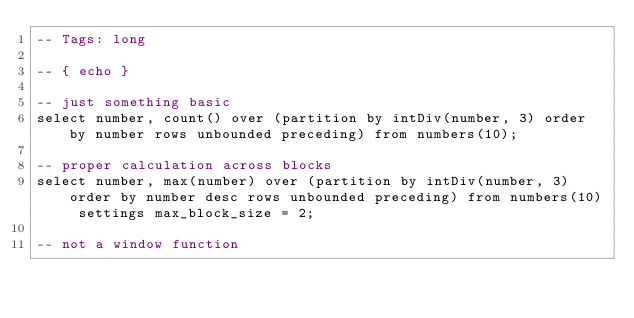Convert code to text. <code><loc_0><loc_0><loc_500><loc_500><_SQL_>-- Tags: long

-- { echo }

-- just something basic
select number, count() over (partition by intDiv(number, 3) order by number rows unbounded preceding) from numbers(10);

-- proper calculation across blocks
select number, max(number) over (partition by intDiv(number, 3) order by number desc rows unbounded preceding) from numbers(10) settings max_block_size = 2;

-- not a window function</code> 